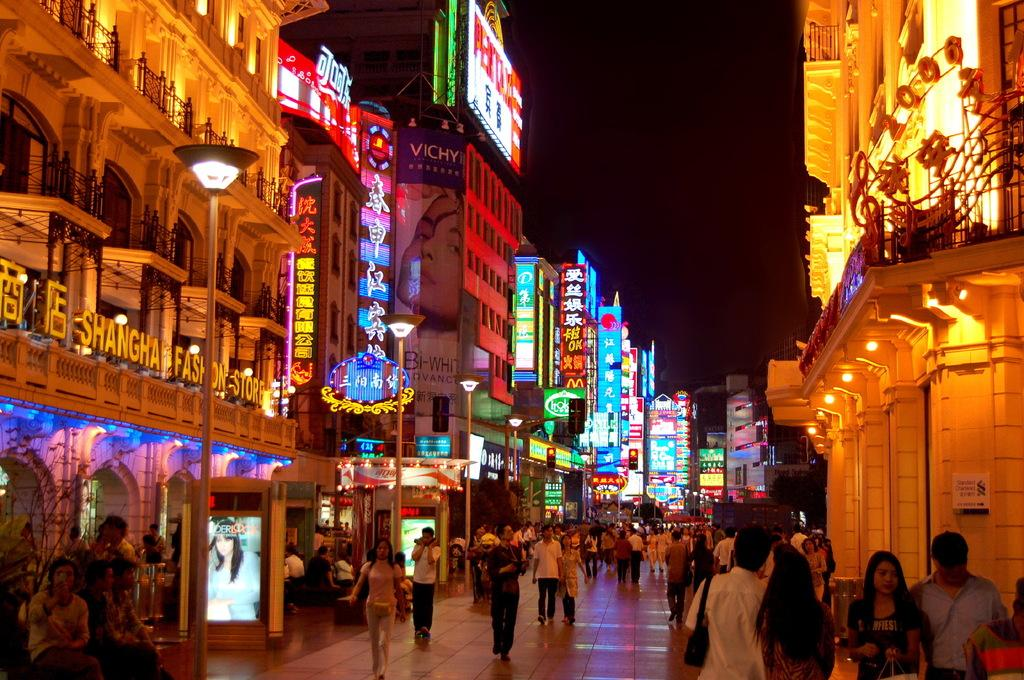Provide a one-sentence caption for the provided image. Shanghai fashion store on a building with chinese symbols. 